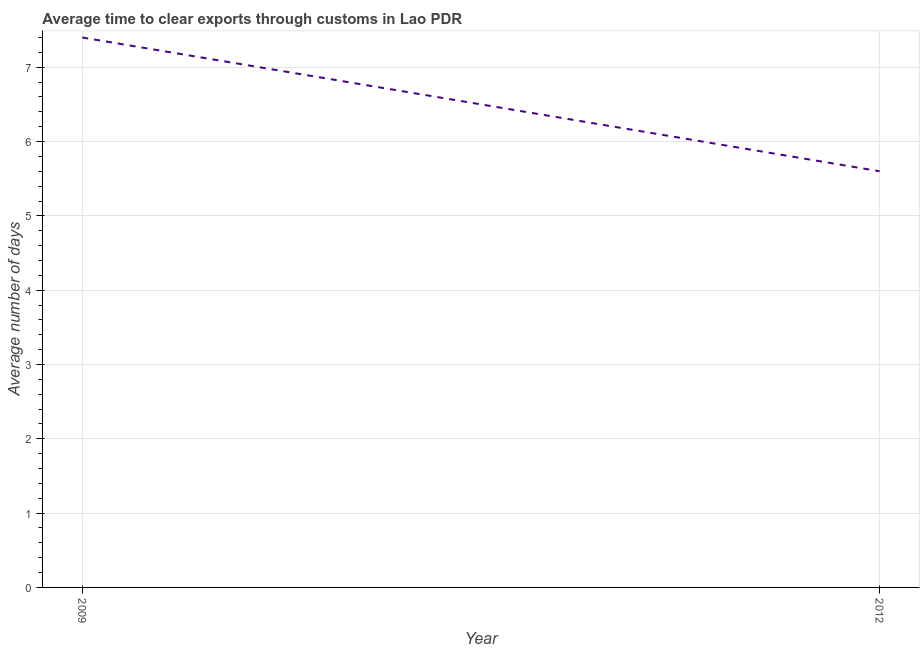What is the time to clear exports through customs in 2012?
Make the answer very short. 5.6. Across all years, what is the maximum time to clear exports through customs?
Ensure brevity in your answer.  7.4. In which year was the time to clear exports through customs maximum?
Your answer should be very brief. 2009. In which year was the time to clear exports through customs minimum?
Offer a very short reply. 2012. What is the sum of the time to clear exports through customs?
Provide a succinct answer. 13. What is the difference between the time to clear exports through customs in 2009 and 2012?
Keep it short and to the point. 1.8. What is the average time to clear exports through customs per year?
Offer a terse response. 6.5. What is the median time to clear exports through customs?
Your response must be concise. 6.5. What is the ratio of the time to clear exports through customs in 2009 to that in 2012?
Give a very brief answer. 1.32. In how many years, is the time to clear exports through customs greater than the average time to clear exports through customs taken over all years?
Provide a succinct answer. 1. What is the difference between two consecutive major ticks on the Y-axis?
Offer a very short reply. 1. Are the values on the major ticks of Y-axis written in scientific E-notation?
Your answer should be very brief. No. What is the title of the graph?
Offer a terse response. Average time to clear exports through customs in Lao PDR. What is the label or title of the Y-axis?
Give a very brief answer. Average number of days. What is the Average number of days of 2009?
Make the answer very short. 7.4. What is the difference between the Average number of days in 2009 and 2012?
Your answer should be compact. 1.8. What is the ratio of the Average number of days in 2009 to that in 2012?
Your answer should be very brief. 1.32. 